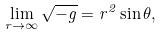<formula> <loc_0><loc_0><loc_500><loc_500>\lim _ { r \rightarrow \infty } \sqrt { - g } = r ^ { 2 } \sin \theta ,</formula> 